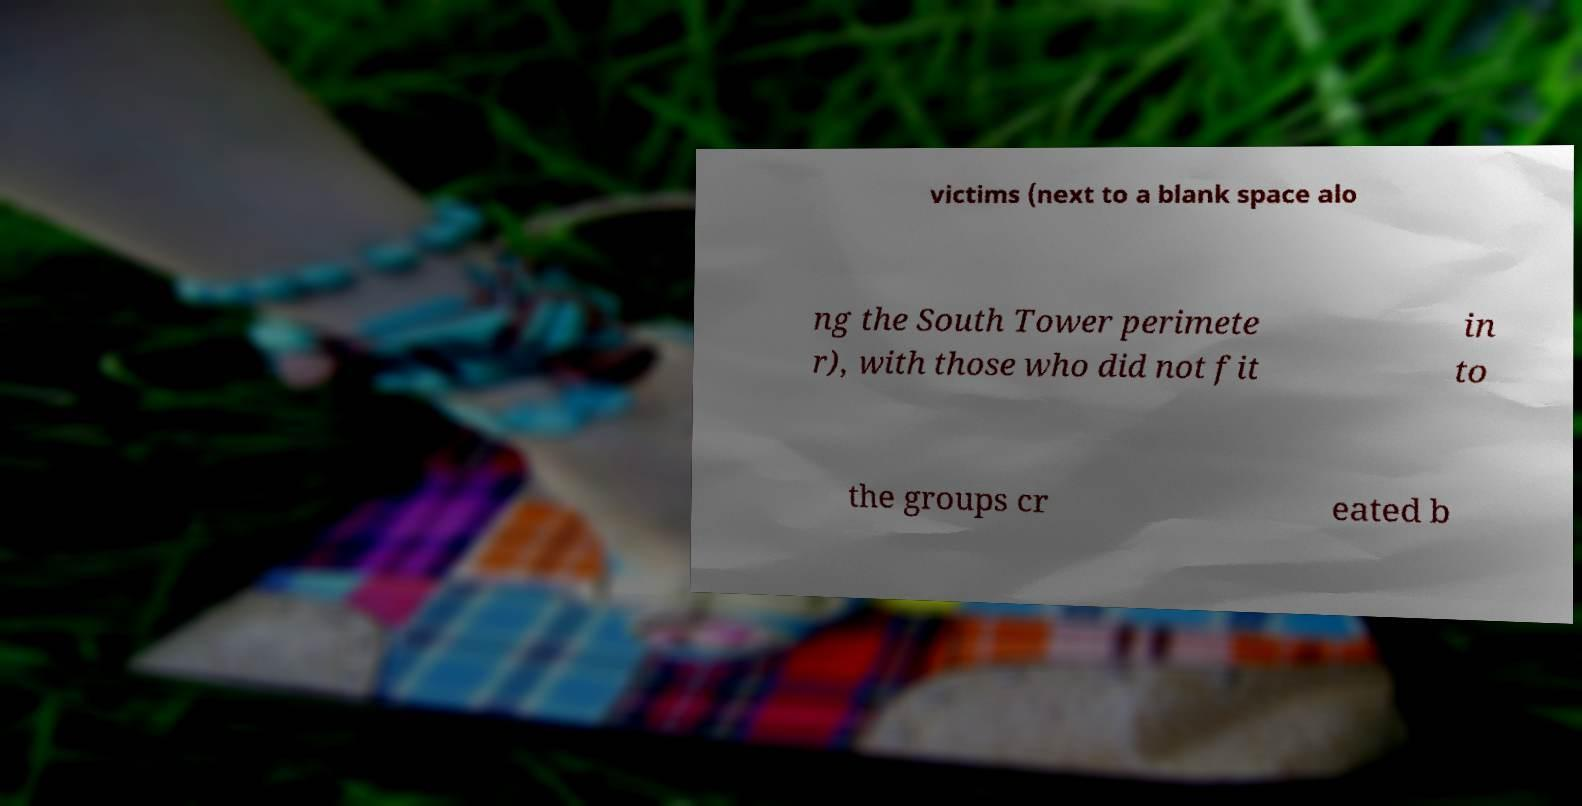Could you assist in decoding the text presented in this image and type it out clearly? victims (next to a blank space alo ng the South Tower perimete r), with those who did not fit in to the groups cr eated b 